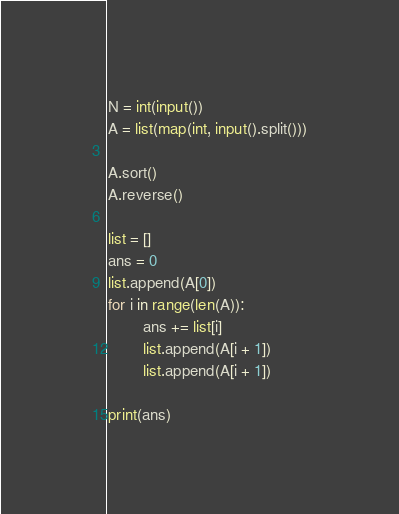<code> <loc_0><loc_0><loc_500><loc_500><_Python_>N = int(input())
A = list(map(int, input().split()))

A.sort()
A.reverse()

list = []
ans = 0
list.append(A[0])
for i in range(len(A)):
        ans += list[i]
        list.append(A[i + 1])
        list.append(A[i + 1])

print(ans)</code> 